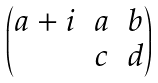<formula> <loc_0><loc_0><loc_500><loc_500>\begin{pmatrix} a + i & a & b \\ & c & d \end{pmatrix}</formula> 